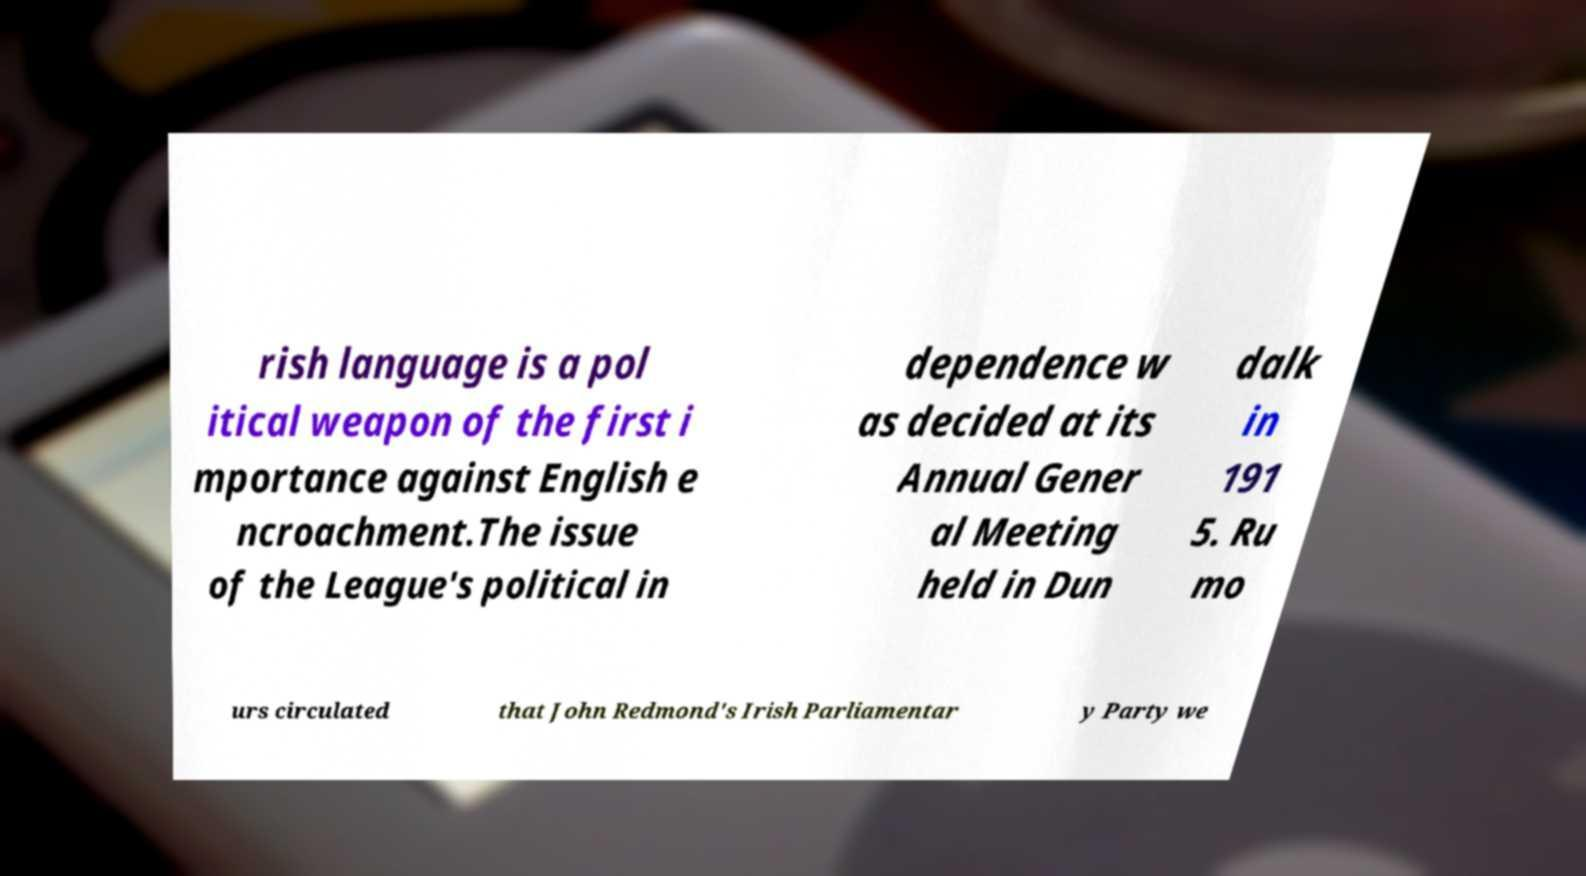What messages or text are displayed in this image? I need them in a readable, typed format. rish language is a pol itical weapon of the first i mportance against English e ncroachment.The issue of the League's political in dependence w as decided at its Annual Gener al Meeting held in Dun dalk in 191 5. Ru mo urs circulated that John Redmond's Irish Parliamentar y Party we 